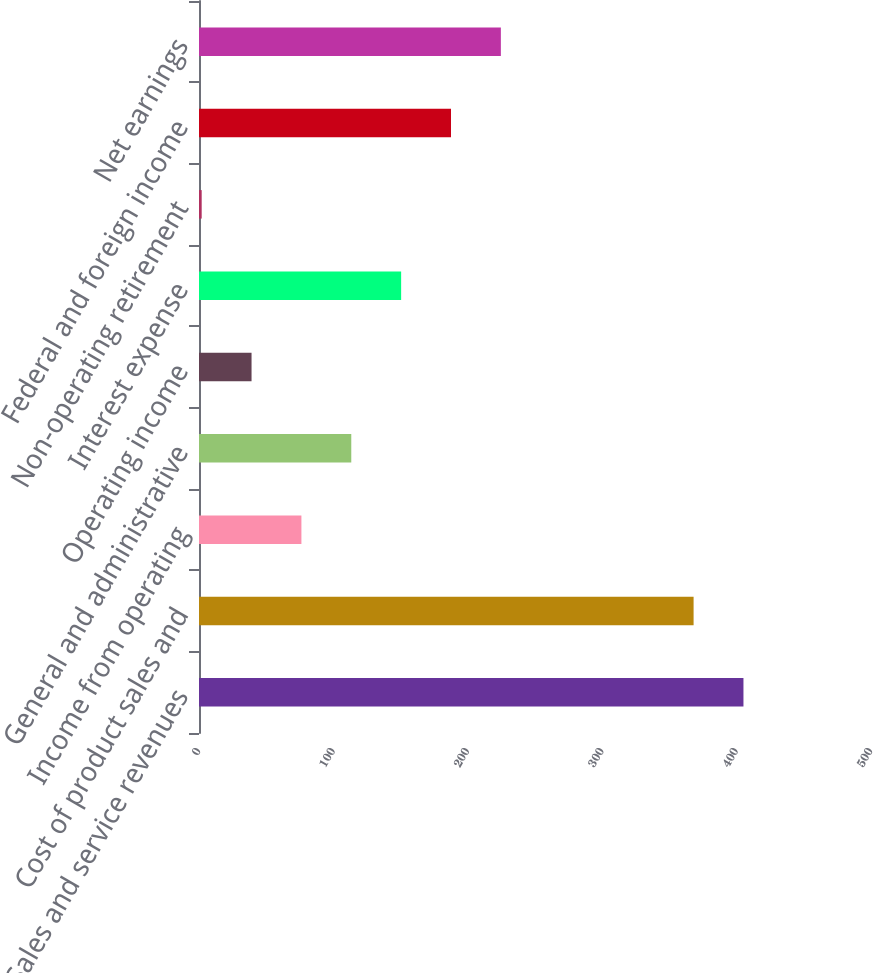Convert chart to OTSL. <chart><loc_0><loc_0><loc_500><loc_500><bar_chart><fcel>Sales and service revenues<fcel>Cost of product sales and<fcel>Income from operating<fcel>General and administrative<fcel>Operating income<fcel>Interest expense<fcel>Non-operating retirement<fcel>Federal and foreign income<fcel>Net earnings<nl><fcel>405.1<fcel>368<fcel>76.2<fcel>113.3<fcel>39.1<fcel>150.4<fcel>2<fcel>187.5<fcel>224.6<nl></chart> 